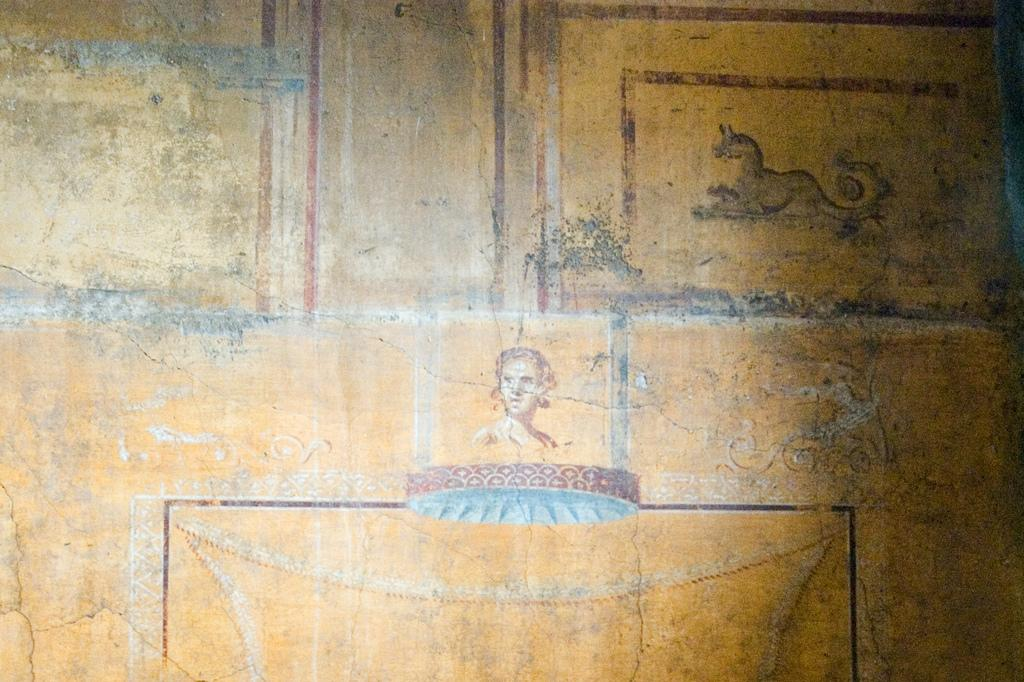What is depicted on the wall in the image? There are arts on the wall in the image. What is the color of the wall? The wall is yellow in color. Can you describe the main subject of the art in the middle of the image? There is an art of a human in the middle of the image. How many dolls are sitting on the beetle in the image? There are no dolls or beetles present in the image. 